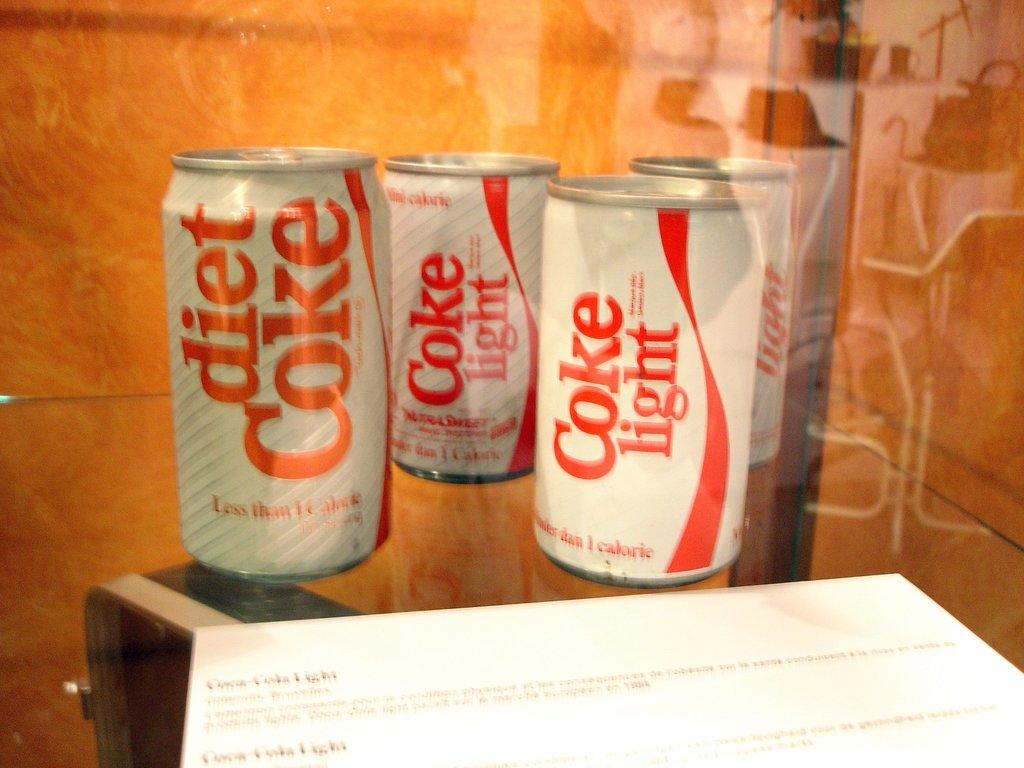<image>
Give a short and clear explanation of the subsequent image. A white and red can of Coke Light sits on a glass table. 